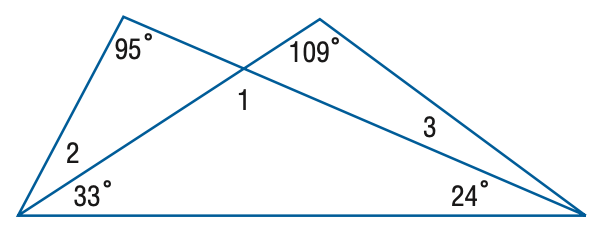Answer the mathemtical geometry problem and directly provide the correct option letter.
Question: Find the measure of \angle 1.
Choices: A: 95 B: 109 C: 123 D: 137 C 